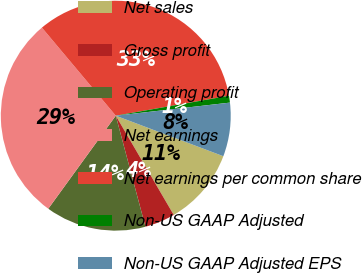<chart> <loc_0><loc_0><loc_500><loc_500><pie_chart><fcel>Net sales<fcel>Gross profit<fcel>Operating profit<fcel>Net earnings<fcel>Net earnings per common share<fcel>Non-US GAAP Adjusted<fcel>Non-US GAAP Adjusted EPS<nl><fcel>10.85%<fcel>4.26%<fcel>14.14%<fcel>28.9%<fcel>33.33%<fcel>0.96%<fcel>7.55%<nl></chart> 